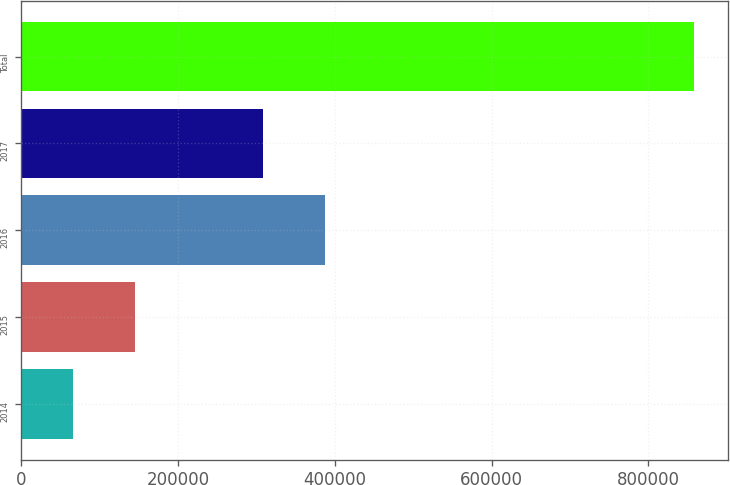<chart> <loc_0><loc_0><loc_500><loc_500><bar_chart><fcel>2014<fcel>2015<fcel>2016<fcel>2017<fcel>Total<nl><fcel>66000<fcel>145200<fcel>387200<fcel>308000<fcel>858000<nl></chart> 